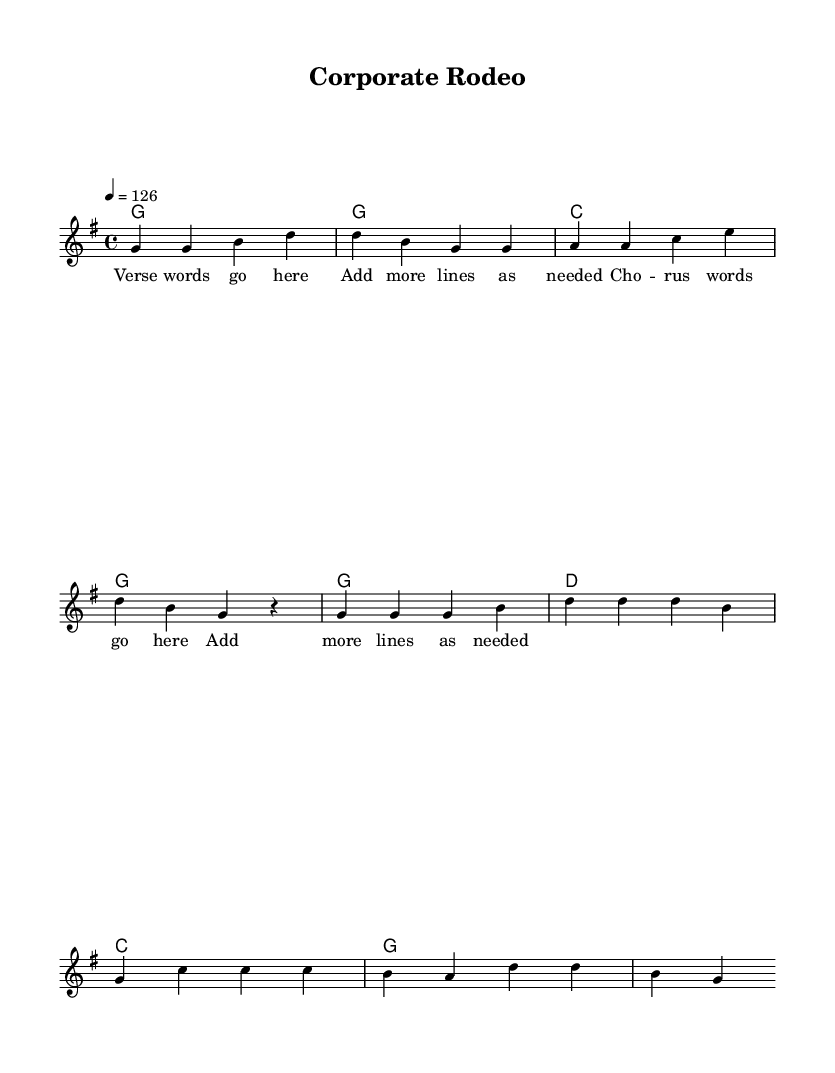What is the key signature of this music? The key signature is G major, which has one sharp (F#). This can be identified at the beginning of the sheet music where the key signature is indicated.
Answer: G major What is the time signature of this music? The time signature is 4/4, which is shown in the beginning of the sheet music. This indicates that there are four beats in a measure and the quarter note gets one beat.
Answer: 4/4 What is the tempo marking for this piece? The tempo marking is quarter note equals 126, which indicates the speed of the piece. It can be found at the beginning of the sheet music.
Answer: 126 How many measures are in the verse section? The verse section contains 4 measures, as can be counted from the melody line for the verse, which has 4 groups of rhythmic counts.
Answer: 4 What is the structure of the song? The structure consists of a verse followed by a chorus. The verse and chorus are indicated in the layout of the music, where different sections are labeled.
Answer: Verse and Chorus What are the first three notes of the melody? The first three notes of the melody are G, G, B. This can be verified by looking at the melody line at the start of the piece, which precisely shows these notes.
Answer: G, G, B What is the chord for the chorus? The chord for the chorus starts with G major, as seen in the harmonies section where it first appears. This shows the root chord that supports the main melody during the chorus.
Answer: G 